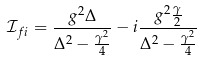Convert formula to latex. <formula><loc_0><loc_0><loc_500><loc_500>\mathcal { I } _ { f i } = \frac { g ^ { 2 } \Delta } { \Delta ^ { 2 } - \frac { \gamma ^ { 2 } } { 4 } } - i \frac { g ^ { 2 } \frac { \gamma } { 2 } } { \Delta ^ { 2 } - \frac { \gamma ^ { 2 } } { 4 } }</formula> 